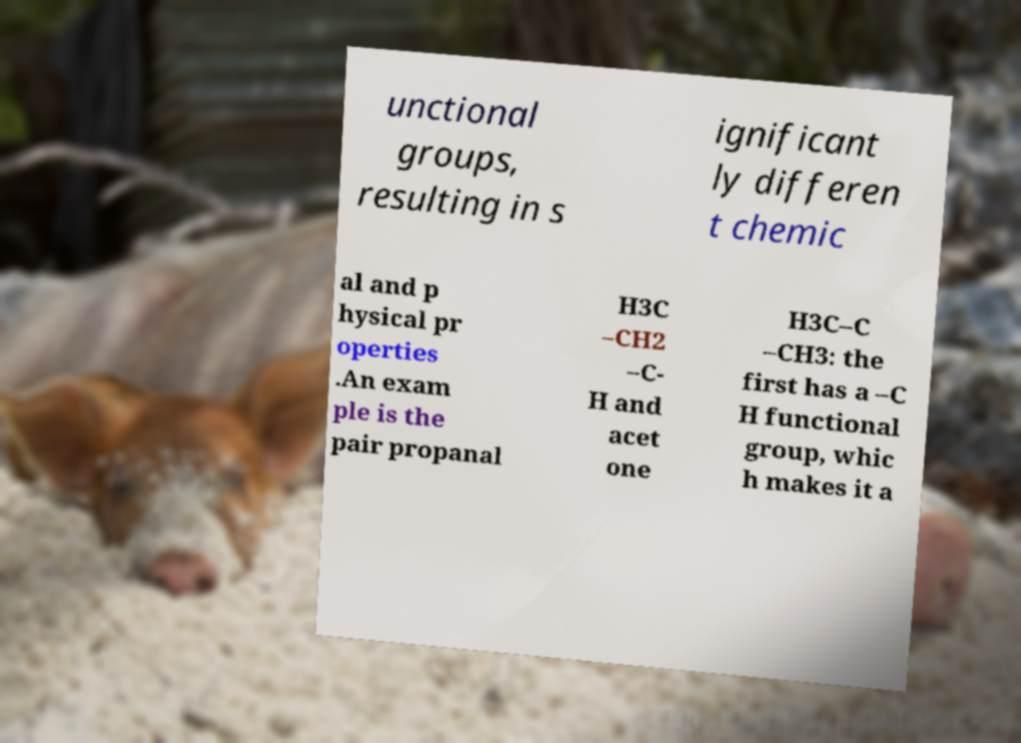Can you accurately transcribe the text from the provided image for me? unctional groups, resulting in s ignificant ly differen t chemic al and p hysical pr operties .An exam ple is the pair propanal H3C –CH2 –C- H and acet one H3C–C –CH3: the first has a –C H functional group, whic h makes it a 